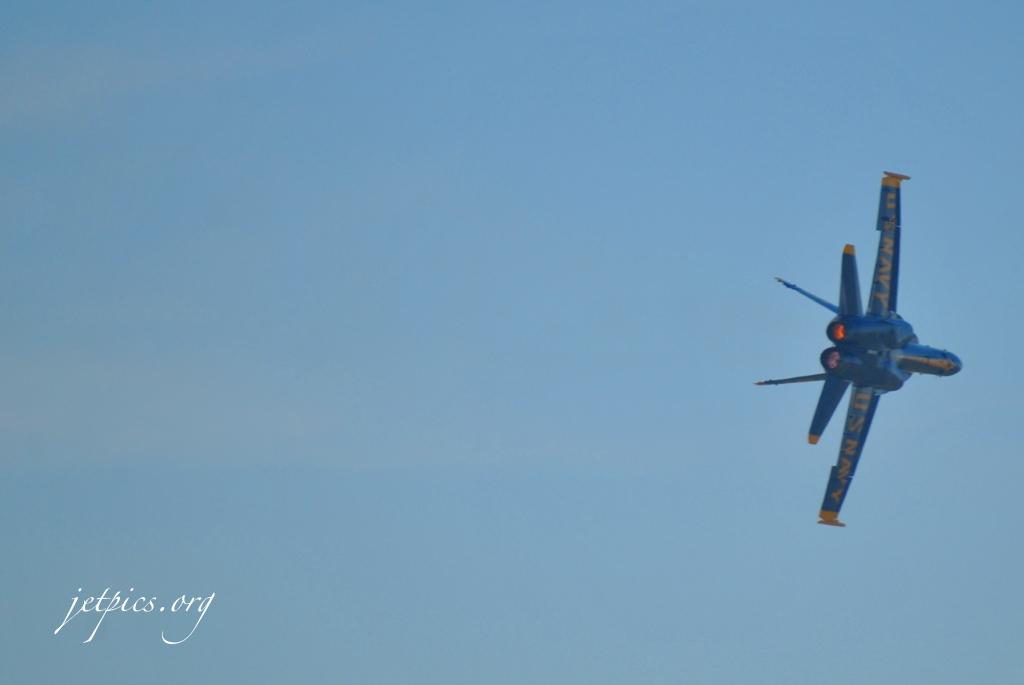What is the main subject of the picture? The main subject of the picture is a fighter jet. Is there any text present in the image? Yes, there is text at the bottom left corner of the picture. How would you describe the sky in the picture? The sky is blue and cloudy in the picture. Can you see the ocean in the background of the picture? There is no ocean visible in the picture; it features a fighter jet and a blue, cloudy sky. Is the fighter jet on fire in the image? The fighter jet is not on fire in the image; it appears to be in a normal, non-combustible state. 